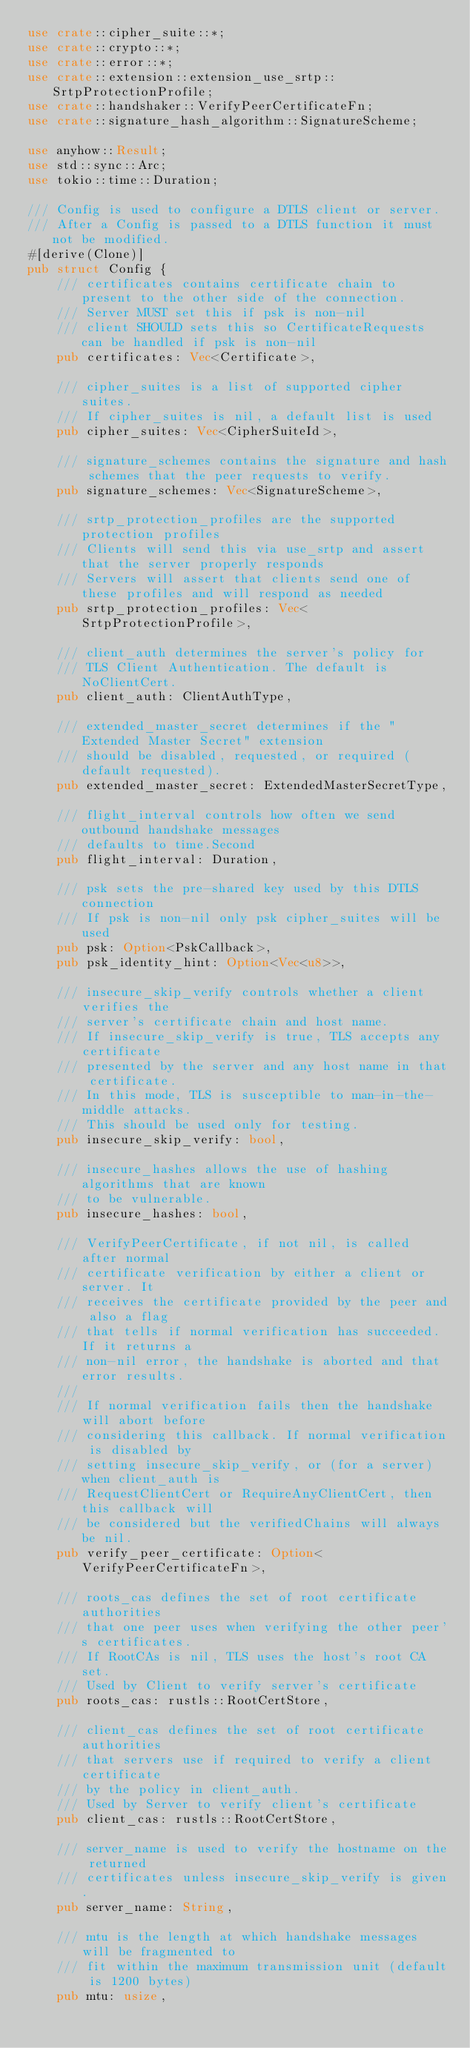Convert code to text. <code><loc_0><loc_0><loc_500><loc_500><_Rust_>use crate::cipher_suite::*;
use crate::crypto::*;
use crate::error::*;
use crate::extension::extension_use_srtp::SrtpProtectionProfile;
use crate::handshaker::VerifyPeerCertificateFn;
use crate::signature_hash_algorithm::SignatureScheme;

use anyhow::Result;
use std::sync::Arc;
use tokio::time::Duration;

/// Config is used to configure a DTLS client or server.
/// After a Config is passed to a DTLS function it must not be modified.
#[derive(Clone)]
pub struct Config {
    /// certificates contains certificate chain to present to the other side of the connection.
    /// Server MUST set this if psk is non-nil
    /// client SHOULD sets this so CertificateRequests can be handled if psk is non-nil
    pub certificates: Vec<Certificate>,

    /// cipher_suites is a list of supported cipher suites.
    /// If cipher_suites is nil, a default list is used
    pub cipher_suites: Vec<CipherSuiteId>,

    /// signature_schemes contains the signature and hash schemes that the peer requests to verify.
    pub signature_schemes: Vec<SignatureScheme>,

    /// srtp_protection_profiles are the supported protection profiles
    /// Clients will send this via use_srtp and assert that the server properly responds
    /// Servers will assert that clients send one of these profiles and will respond as needed
    pub srtp_protection_profiles: Vec<SrtpProtectionProfile>,

    /// client_auth determines the server's policy for
    /// TLS Client Authentication. The default is NoClientCert.
    pub client_auth: ClientAuthType,

    /// extended_master_secret determines if the "Extended Master Secret" extension
    /// should be disabled, requested, or required (default requested).
    pub extended_master_secret: ExtendedMasterSecretType,

    /// flight_interval controls how often we send outbound handshake messages
    /// defaults to time.Second
    pub flight_interval: Duration,

    /// psk sets the pre-shared key used by this DTLS connection
    /// If psk is non-nil only psk cipher_suites will be used
    pub psk: Option<PskCallback>,
    pub psk_identity_hint: Option<Vec<u8>>,

    /// insecure_skip_verify controls whether a client verifies the
    /// server's certificate chain and host name.
    /// If insecure_skip_verify is true, TLS accepts any certificate
    /// presented by the server and any host name in that certificate.
    /// In this mode, TLS is susceptible to man-in-the-middle attacks.
    /// This should be used only for testing.
    pub insecure_skip_verify: bool,

    /// insecure_hashes allows the use of hashing algorithms that are known
    /// to be vulnerable.
    pub insecure_hashes: bool,

    /// VerifyPeerCertificate, if not nil, is called after normal
    /// certificate verification by either a client or server. It
    /// receives the certificate provided by the peer and also a flag
    /// that tells if normal verification has succeeded. If it returns a
    /// non-nil error, the handshake is aborted and that error results.
    ///
    /// If normal verification fails then the handshake will abort before
    /// considering this callback. If normal verification is disabled by
    /// setting insecure_skip_verify, or (for a server) when client_auth is
    /// RequestClientCert or RequireAnyClientCert, then this callback will
    /// be considered but the verifiedChains will always be nil.
    pub verify_peer_certificate: Option<VerifyPeerCertificateFn>,

    /// roots_cas defines the set of root certificate authorities
    /// that one peer uses when verifying the other peer's certificates.
    /// If RootCAs is nil, TLS uses the host's root CA set.
    /// Used by Client to verify server's certificate
    pub roots_cas: rustls::RootCertStore,

    /// client_cas defines the set of root certificate authorities
    /// that servers use if required to verify a client certificate
    /// by the policy in client_auth.
    /// Used by Server to verify client's certificate
    pub client_cas: rustls::RootCertStore,

    /// server_name is used to verify the hostname on the returned
    /// certificates unless insecure_skip_verify is given.
    pub server_name: String,

    /// mtu is the length at which handshake messages will be fragmented to
    /// fit within the maximum transmission unit (default is 1200 bytes)
    pub mtu: usize,
</code> 